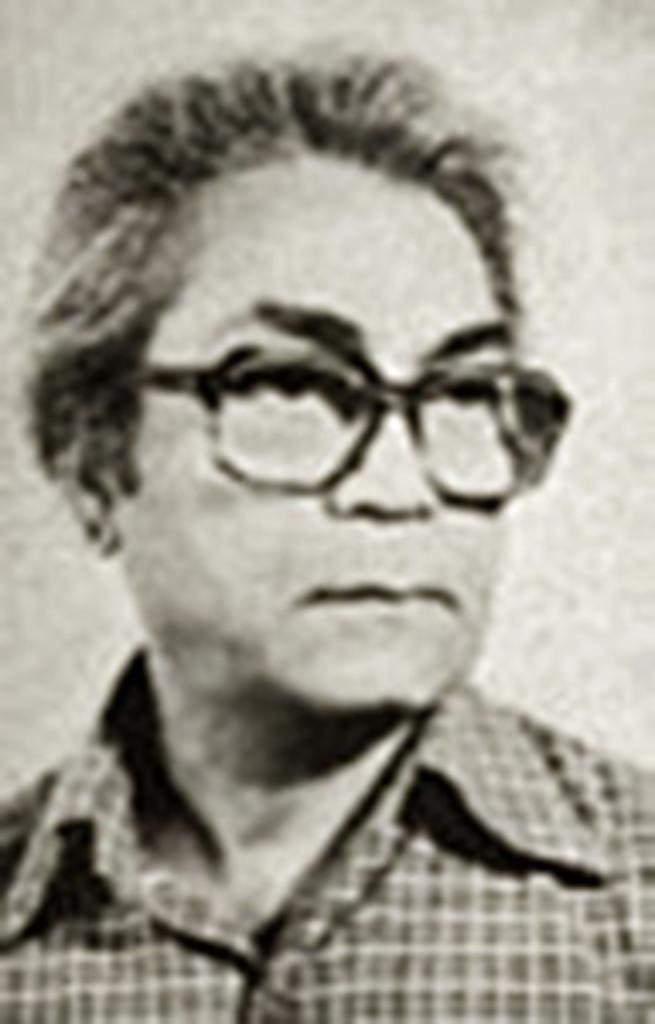What is the main subject of the image? There is a man in the image. How many clocks are visible on the man's property in the image? There is no information about the man's property or any clocks in the image. 